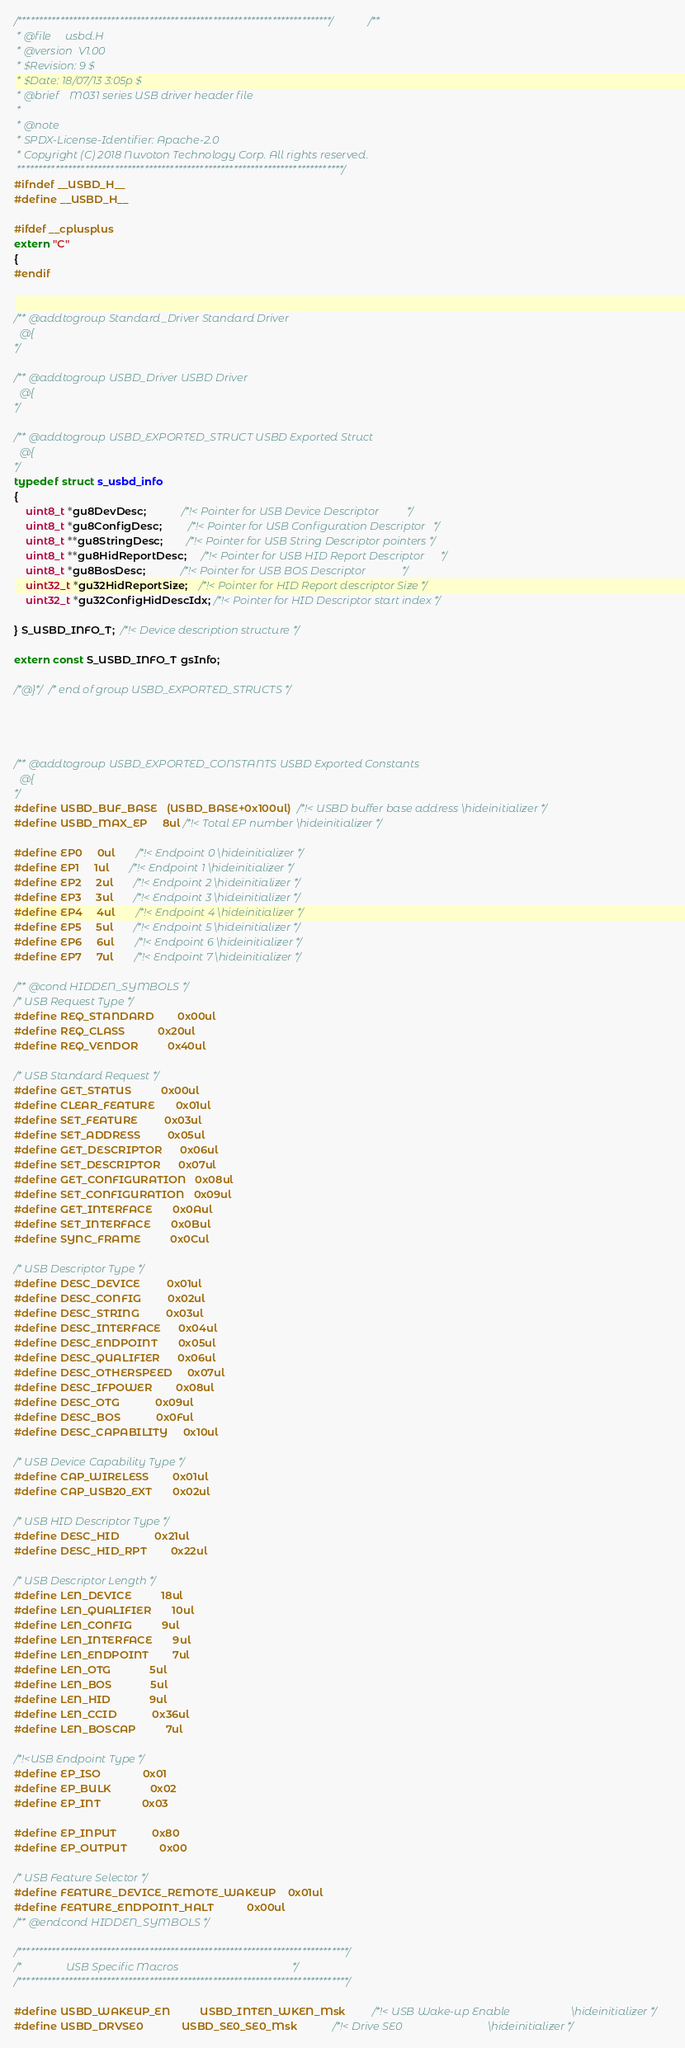<code> <loc_0><loc_0><loc_500><loc_500><_C_>
/**************************************************************************//**
 * @file     usbd.H
 * @version  V1.00
 * $Revision: 9 $
 * $Date: 18/07/13 3:05p $
 * @brief    M031 series USB driver header file
 *
 * @note
 * SPDX-License-Identifier: Apache-2.0
 * Copyright (C) 2018 Nuvoton Technology Corp. All rights reserved.
 *****************************************************************************/
#ifndef __USBD_H__
#define __USBD_H__

#ifdef __cplusplus
extern "C"
{
#endif


/** @addtogroup Standard_Driver Standard Driver
  @{
*/

/** @addtogroup USBD_Driver USBD Driver
  @{
*/

/** @addtogroup USBD_EXPORTED_STRUCT USBD Exported Struct
  @{
*/
typedef struct s_usbd_info
{
    uint8_t *gu8DevDesc;            /*!< Pointer for USB Device Descriptor          */
    uint8_t *gu8ConfigDesc;         /*!< Pointer for USB Configuration Descriptor   */
    uint8_t **gu8StringDesc;        /*!< Pointer for USB String Descriptor pointers */
    uint8_t **gu8HidReportDesc;     /*!< Pointer for USB HID Report Descriptor      */
    uint8_t *gu8BosDesc;            /*!< Pointer for USB BOS Descriptor             */
    uint32_t *gu32HidReportSize;    /*!< Pointer for HID Report descriptor Size */
    uint32_t *gu32ConfigHidDescIdx; /*!< Pointer for HID Descriptor start index */

} S_USBD_INFO_T;  /*!< Device description structure */

extern const S_USBD_INFO_T gsInfo;

/*@}*/ /* end of group USBD_EXPORTED_STRUCTS */




/** @addtogroup USBD_EXPORTED_CONSTANTS USBD Exported Constants
  @{
*/
#define USBD_BUF_BASE   (USBD_BASE+0x100ul)  /*!< USBD buffer base address \hideinitializer */
#define USBD_MAX_EP     8ul /*!< Total EP number \hideinitializer */

#define EP0     0ul       /*!< Endpoint 0 \hideinitializer */
#define EP1     1ul       /*!< Endpoint 1 \hideinitializer */
#define EP2     2ul       /*!< Endpoint 2 \hideinitializer */
#define EP3     3ul       /*!< Endpoint 3 \hideinitializer */
#define EP4     4ul       /*!< Endpoint 4 \hideinitializer */
#define EP5     5ul       /*!< Endpoint 5 \hideinitializer */
#define EP6     6ul       /*!< Endpoint 6 \hideinitializer */
#define EP7     7ul       /*!< Endpoint 7 \hideinitializer */

/** @cond HIDDEN_SYMBOLS */
/* USB Request Type */
#define REQ_STANDARD        0x00ul
#define REQ_CLASS           0x20ul
#define REQ_VENDOR          0x40ul

/* USB Standard Request */
#define GET_STATUS          0x00ul
#define CLEAR_FEATURE       0x01ul
#define SET_FEATURE         0x03ul
#define SET_ADDRESS         0x05ul
#define GET_DESCRIPTOR      0x06ul
#define SET_DESCRIPTOR      0x07ul
#define GET_CONFIGURATION   0x08ul
#define SET_CONFIGURATION   0x09ul
#define GET_INTERFACE       0x0Aul
#define SET_INTERFACE       0x0Bul
#define SYNC_FRAME          0x0Cul

/* USB Descriptor Type */
#define DESC_DEVICE         0x01ul
#define DESC_CONFIG         0x02ul
#define DESC_STRING         0x03ul
#define DESC_INTERFACE      0x04ul
#define DESC_ENDPOINT       0x05ul
#define DESC_QUALIFIER      0x06ul
#define DESC_OTHERSPEED     0x07ul
#define DESC_IFPOWER        0x08ul
#define DESC_OTG            0x09ul
#define DESC_BOS            0x0Ful
#define DESC_CAPABILITY     0x10ul

/* USB Device Capability Type */
#define CAP_WIRELESS        0x01ul
#define CAP_USB20_EXT       0x02ul

/* USB HID Descriptor Type */
#define DESC_HID            0x21ul
#define DESC_HID_RPT        0x22ul

/* USB Descriptor Length */
#define LEN_DEVICE          18ul
#define LEN_QUALIFIER       10ul
#define LEN_CONFIG          9ul
#define LEN_INTERFACE       9ul
#define LEN_ENDPOINT        7ul
#define LEN_OTG             5ul
#define LEN_BOS             5ul
#define LEN_HID             9ul
#define LEN_CCID            0x36ul
#define LEN_BOSCAP          7ul

/*!<USB Endpoint Type */
#define EP_ISO              0x01
#define EP_BULK             0x02
#define EP_INT              0x03

#define EP_INPUT            0x80
#define EP_OUTPUT           0x00

/* USB Feature Selector */
#define FEATURE_DEVICE_REMOTE_WAKEUP    0x01ul
#define FEATURE_ENDPOINT_HALT           0x00ul
/** @endcond HIDDEN_SYMBOLS */

/******************************************************************************/
/*                USB Specific Macros                                         */
/******************************************************************************/

#define USBD_WAKEUP_EN          USBD_INTEN_WKEN_Msk         /*!< USB Wake-up Enable                      \hideinitializer */
#define USBD_DRVSE0             USBD_SE0_SE0_Msk            /*!< Drive SE0                               \hideinitializer */</code> 